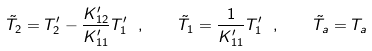Convert formula to latex. <formula><loc_0><loc_0><loc_500><loc_500>\tilde { T } _ { 2 } = T _ { 2 } ^ { \prime } - \frac { K ^ { \prime } _ { 1 2 } } { K ^ { \prime } _ { 1 1 } } T _ { 1 } ^ { \prime } \ , \quad \tilde { T } _ { 1 } = \frac { 1 } { K ^ { \prime } _ { 1 1 } } T _ { 1 } ^ { \prime } \ , \quad \tilde { T } _ { a } = T _ { a }</formula> 